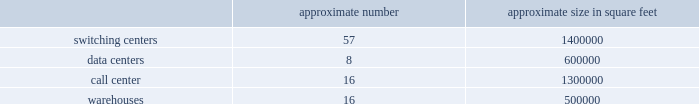Does not believe are in our and our stockholders 2019 best interest .
The rights plan is intended to protect stockholders in the event of an unfair or coercive offer to acquire the company and to provide our board of directors with adequate time to evaluate unsolicited offers .
The rights plan may prevent or make takeovers or unsolicited corporate transactions with respect to our company more difficult , even if stockholders may consider such transactions favorable , possibly including transactions in which stockholders might otherwise receive a premium for their shares .
Item 1b .
Unresolved staff comments item 2 .
Properties as of december 31 , 2016 , our significant properties used in connection with switching centers , data centers , call centers and warehouses were as follows: .
As of december 31 , 2016 , we leased approximately 60000 cell sites .
As of december 31 , 2016 , we leased approximately 2000 t-mobile and metropcs retail locations , including stores and kiosks ranging in size from approximately 100 square feet to 17000 square feet .
We currently lease office space totaling approximately 950000 square feet for our corporate headquarters in bellevue , washington .
We use these offices for engineering and administrative purposes .
We also lease space throughout the u.s. , totaling approximately 1200000 square feet as of december 31 , 2016 , for use by our regional offices primarily for administrative , engineering and sales purposes .
Item 3 .
Legal proceedings see note 12 2013 commitments and contingencies of the notes to the consolidated financial statements included in part ii , item 8 of this form 10-k for information regarding certain legal proceedings in which we are involved .
Item 4 .
Mine safety disclosures part ii .
Item 5 .
Market for registrant 2019s common equity , related stockholder matters and issuer purchases of equity securities market information our common stock is traded on the nasdaq global select market of the nasdaq stock market llc ( 201cnasdaq 201d ) under the symbol 201ctmus . 201d as of december 31 , 2016 , there were 309 registered stockholders of record of our common stock , but we estimate the total number of stockholders to be much higher as a number of our shares are held by brokers or dealers for their customers in street name. .
What is the ratio of the call center to the switching centers in square feet? 
Rationale: for every 0.93 feet of call center space there is 1 square foot of switch center space
Computations: (1300000 / 1400000)
Answer: 0.92857. Does not believe are in our and our stockholders 2019 best interest .
The rights plan is intended to protect stockholders in the event of an unfair or coercive offer to acquire the company and to provide our board of directors with adequate time to evaluate unsolicited offers .
The rights plan may prevent or make takeovers or unsolicited corporate transactions with respect to our company more difficult , even if stockholders may consider such transactions favorable , possibly including transactions in which stockholders might otherwise receive a premium for their shares .
Item 1b .
Unresolved staff comments item 2 .
Properties as of december 31 , 2016 , our significant properties used in connection with switching centers , data centers , call centers and warehouses were as follows: .
As of december 31 , 2016 , we leased approximately 60000 cell sites .
As of december 31 , 2016 , we leased approximately 2000 t-mobile and metropcs retail locations , including stores and kiosks ranging in size from approximately 100 square feet to 17000 square feet .
We currently lease office space totaling approximately 950000 square feet for our corporate headquarters in bellevue , washington .
We use these offices for engineering and administrative purposes .
We also lease space throughout the u.s. , totaling approximately 1200000 square feet as of december 31 , 2016 , for use by our regional offices primarily for administrative , engineering and sales purposes .
Item 3 .
Legal proceedings see note 12 2013 commitments and contingencies of the notes to the consolidated financial statements included in part ii , item 8 of this form 10-k for information regarding certain legal proceedings in which we are involved .
Item 4 .
Mine safety disclosures part ii .
Item 5 .
Market for registrant 2019s common equity , related stockholder matters and issuer purchases of equity securities market information our common stock is traded on the nasdaq global select market of the nasdaq stock market llc ( 201cnasdaq 201d ) under the symbol 201ctmus . 201d as of december 31 , 2016 , there were 309 registered stockholders of record of our common stock , but we estimate the total number of stockholders to be much higher as a number of our shares are held by brokers or dealers for their customers in street name. .
As of 2016 , what was the average size of data centers? 
Computations: (600000 / 8)
Answer: 75000.0. 